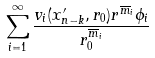<formula> <loc_0><loc_0><loc_500><loc_500>\sum _ { i = 1 } ^ { \infty } \frac { v _ { i } ( x ^ { \prime } _ { n - k } , r _ { 0 } ) r ^ { \overline { m } _ { i } } \phi _ { i } } { r _ { 0 } ^ { \overline { m } _ { i } } }</formula> 